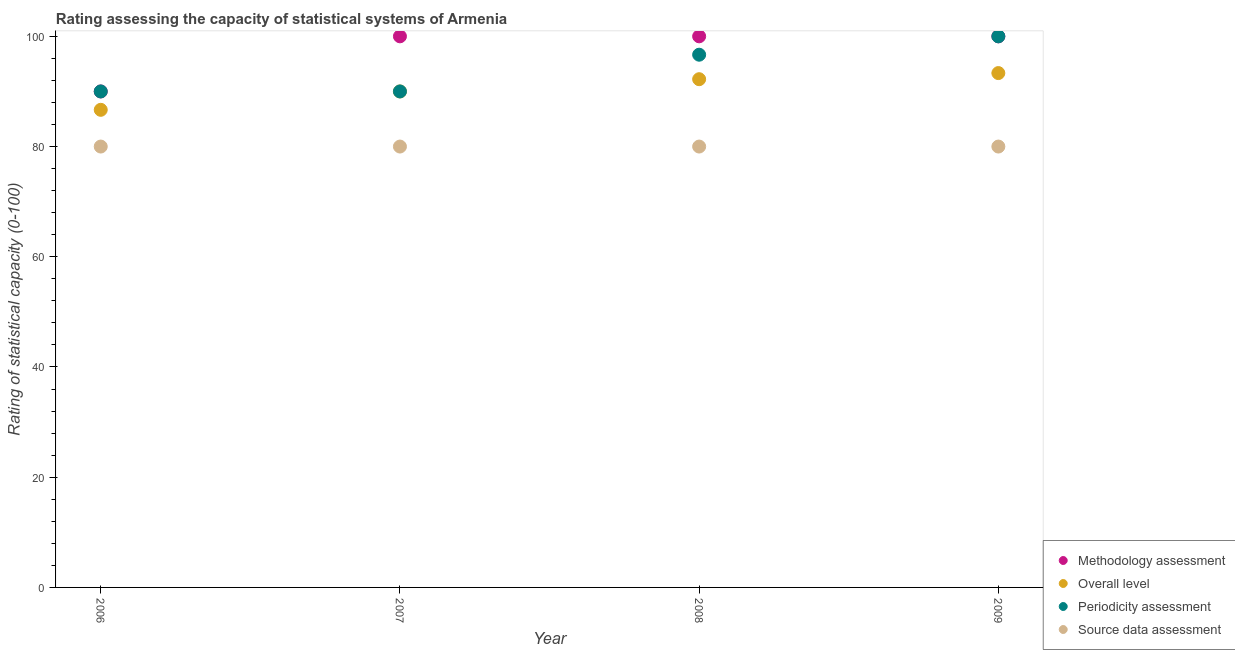How many different coloured dotlines are there?
Offer a terse response. 4. What is the source data assessment rating in 2008?
Your response must be concise. 80. Across all years, what is the maximum periodicity assessment rating?
Provide a short and direct response. 100. What is the total periodicity assessment rating in the graph?
Your answer should be compact. 376.67. What is the difference between the methodology assessment rating in 2006 and that in 2009?
Your answer should be very brief. -10. What is the difference between the overall level rating in 2007 and the source data assessment rating in 2008?
Keep it short and to the point. 10. What is the average overall level rating per year?
Keep it short and to the point. 90.56. In the year 2006, what is the difference between the methodology assessment rating and source data assessment rating?
Keep it short and to the point. 10. Is the difference between the methodology assessment rating in 2007 and 2008 greater than the difference between the overall level rating in 2007 and 2008?
Provide a succinct answer. Yes. What is the difference between the highest and the second highest periodicity assessment rating?
Keep it short and to the point. 3.33. Is the sum of the periodicity assessment rating in 2008 and 2009 greater than the maximum overall level rating across all years?
Your answer should be compact. Yes. Is it the case that in every year, the sum of the methodology assessment rating and overall level rating is greater than the periodicity assessment rating?
Provide a succinct answer. Yes. Does the periodicity assessment rating monotonically increase over the years?
Make the answer very short. No. How many years are there in the graph?
Ensure brevity in your answer.  4. What is the difference between two consecutive major ticks on the Y-axis?
Make the answer very short. 20. Does the graph contain any zero values?
Provide a short and direct response. No. Does the graph contain grids?
Give a very brief answer. No. What is the title of the graph?
Offer a terse response. Rating assessing the capacity of statistical systems of Armenia. Does "Social Insurance" appear as one of the legend labels in the graph?
Provide a short and direct response. No. What is the label or title of the Y-axis?
Your answer should be very brief. Rating of statistical capacity (0-100). What is the Rating of statistical capacity (0-100) in Overall level in 2006?
Ensure brevity in your answer.  86.67. What is the Rating of statistical capacity (0-100) in Source data assessment in 2006?
Provide a succinct answer. 80. What is the Rating of statistical capacity (0-100) of Methodology assessment in 2007?
Offer a terse response. 100. What is the Rating of statistical capacity (0-100) of Source data assessment in 2007?
Offer a very short reply. 80. What is the Rating of statistical capacity (0-100) of Methodology assessment in 2008?
Offer a terse response. 100. What is the Rating of statistical capacity (0-100) in Overall level in 2008?
Ensure brevity in your answer.  92.22. What is the Rating of statistical capacity (0-100) in Periodicity assessment in 2008?
Provide a succinct answer. 96.67. What is the Rating of statistical capacity (0-100) of Source data assessment in 2008?
Keep it short and to the point. 80. What is the Rating of statistical capacity (0-100) in Overall level in 2009?
Offer a very short reply. 93.33. Across all years, what is the maximum Rating of statistical capacity (0-100) in Methodology assessment?
Offer a very short reply. 100. Across all years, what is the maximum Rating of statistical capacity (0-100) in Overall level?
Provide a succinct answer. 93.33. Across all years, what is the maximum Rating of statistical capacity (0-100) of Periodicity assessment?
Provide a succinct answer. 100. Across all years, what is the minimum Rating of statistical capacity (0-100) of Methodology assessment?
Keep it short and to the point. 90. Across all years, what is the minimum Rating of statistical capacity (0-100) in Overall level?
Provide a short and direct response. 86.67. Across all years, what is the minimum Rating of statistical capacity (0-100) of Periodicity assessment?
Your answer should be very brief. 90. What is the total Rating of statistical capacity (0-100) of Methodology assessment in the graph?
Offer a very short reply. 390. What is the total Rating of statistical capacity (0-100) of Overall level in the graph?
Ensure brevity in your answer.  362.22. What is the total Rating of statistical capacity (0-100) in Periodicity assessment in the graph?
Offer a terse response. 376.67. What is the total Rating of statistical capacity (0-100) of Source data assessment in the graph?
Your response must be concise. 320. What is the difference between the Rating of statistical capacity (0-100) in Source data assessment in 2006 and that in 2007?
Provide a short and direct response. 0. What is the difference between the Rating of statistical capacity (0-100) of Methodology assessment in 2006 and that in 2008?
Ensure brevity in your answer.  -10. What is the difference between the Rating of statistical capacity (0-100) of Overall level in 2006 and that in 2008?
Your answer should be compact. -5.56. What is the difference between the Rating of statistical capacity (0-100) of Periodicity assessment in 2006 and that in 2008?
Keep it short and to the point. -6.67. What is the difference between the Rating of statistical capacity (0-100) in Overall level in 2006 and that in 2009?
Give a very brief answer. -6.67. What is the difference between the Rating of statistical capacity (0-100) in Periodicity assessment in 2006 and that in 2009?
Keep it short and to the point. -10. What is the difference between the Rating of statistical capacity (0-100) in Methodology assessment in 2007 and that in 2008?
Offer a terse response. 0. What is the difference between the Rating of statistical capacity (0-100) in Overall level in 2007 and that in 2008?
Your answer should be compact. -2.22. What is the difference between the Rating of statistical capacity (0-100) of Periodicity assessment in 2007 and that in 2008?
Your answer should be compact. -6.67. What is the difference between the Rating of statistical capacity (0-100) of Overall level in 2007 and that in 2009?
Ensure brevity in your answer.  -3.33. What is the difference between the Rating of statistical capacity (0-100) in Source data assessment in 2007 and that in 2009?
Provide a short and direct response. 0. What is the difference between the Rating of statistical capacity (0-100) in Overall level in 2008 and that in 2009?
Offer a terse response. -1.11. What is the difference between the Rating of statistical capacity (0-100) in Periodicity assessment in 2008 and that in 2009?
Keep it short and to the point. -3.33. What is the difference between the Rating of statistical capacity (0-100) of Source data assessment in 2008 and that in 2009?
Provide a succinct answer. 0. What is the difference between the Rating of statistical capacity (0-100) of Methodology assessment in 2006 and the Rating of statistical capacity (0-100) of Overall level in 2007?
Your answer should be very brief. 0. What is the difference between the Rating of statistical capacity (0-100) in Methodology assessment in 2006 and the Rating of statistical capacity (0-100) in Periodicity assessment in 2007?
Your answer should be very brief. 0. What is the difference between the Rating of statistical capacity (0-100) in Overall level in 2006 and the Rating of statistical capacity (0-100) in Periodicity assessment in 2007?
Provide a short and direct response. -3.33. What is the difference between the Rating of statistical capacity (0-100) of Methodology assessment in 2006 and the Rating of statistical capacity (0-100) of Overall level in 2008?
Your answer should be very brief. -2.22. What is the difference between the Rating of statistical capacity (0-100) in Methodology assessment in 2006 and the Rating of statistical capacity (0-100) in Periodicity assessment in 2008?
Offer a very short reply. -6.67. What is the difference between the Rating of statistical capacity (0-100) of Methodology assessment in 2006 and the Rating of statistical capacity (0-100) of Source data assessment in 2008?
Make the answer very short. 10. What is the difference between the Rating of statistical capacity (0-100) of Overall level in 2006 and the Rating of statistical capacity (0-100) of Periodicity assessment in 2008?
Keep it short and to the point. -10. What is the difference between the Rating of statistical capacity (0-100) in Periodicity assessment in 2006 and the Rating of statistical capacity (0-100) in Source data assessment in 2008?
Your answer should be compact. 10. What is the difference between the Rating of statistical capacity (0-100) of Overall level in 2006 and the Rating of statistical capacity (0-100) of Periodicity assessment in 2009?
Offer a terse response. -13.33. What is the difference between the Rating of statistical capacity (0-100) in Methodology assessment in 2007 and the Rating of statistical capacity (0-100) in Overall level in 2008?
Make the answer very short. 7.78. What is the difference between the Rating of statistical capacity (0-100) in Methodology assessment in 2007 and the Rating of statistical capacity (0-100) in Periodicity assessment in 2008?
Your answer should be compact. 3.33. What is the difference between the Rating of statistical capacity (0-100) in Overall level in 2007 and the Rating of statistical capacity (0-100) in Periodicity assessment in 2008?
Ensure brevity in your answer.  -6.67. What is the difference between the Rating of statistical capacity (0-100) of Methodology assessment in 2007 and the Rating of statistical capacity (0-100) of Overall level in 2009?
Offer a terse response. 6.67. What is the difference between the Rating of statistical capacity (0-100) of Methodology assessment in 2007 and the Rating of statistical capacity (0-100) of Source data assessment in 2009?
Your response must be concise. 20. What is the difference between the Rating of statistical capacity (0-100) in Overall level in 2007 and the Rating of statistical capacity (0-100) in Periodicity assessment in 2009?
Provide a succinct answer. -10. What is the difference between the Rating of statistical capacity (0-100) in Overall level in 2007 and the Rating of statistical capacity (0-100) in Source data assessment in 2009?
Keep it short and to the point. 10. What is the difference between the Rating of statistical capacity (0-100) in Periodicity assessment in 2007 and the Rating of statistical capacity (0-100) in Source data assessment in 2009?
Make the answer very short. 10. What is the difference between the Rating of statistical capacity (0-100) of Methodology assessment in 2008 and the Rating of statistical capacity (0-100) of Overall level in 2009?
Make the answer very short. 6.67. What is the difference between the Rating of statistical capacity (0-100) in Methodology assessment in 2008 and the Rating of statistical capacity (0-100) in Source data assessment in 2009?
Ensure brevity in your answer.  20. What is the difference between the Rating of statistical capacity (0-100) of Overall level in 2008 and the Rating of statistical capacity (0-100) of Periodicity assessment in 2009?
Make the answer very short. -7.78. What is the difference between the Rating of statistical capacity (0-100) in Overall level in 2008 and the Rating of statistical capacity (0-100) in Source data assessment in 2009?
Make the answer very short. 12.22. What is the difference between the Rating of statistical capacity (0-100) of Periodicity assessment in 2008 and the Rating of statistical capacity (0-100) of Source data assessment in 2009?
Give a very brief answer. 16.67. What is the average Rating of statistical capacity (0-100) of Methodology assessment per year?
Give a very brief answer. 97.5. What is the average Rating of statistical capacity (0-100) of Overall level per year?
Offer a terse response. 90.56. What is the average Rating of statistical capacity (0-100) in Periodicity assessment per year?
Your answer should be compact. 94.17. In the year 2006, what is the difference between the Rating of statistical capacity (0-100) in Methodology assessment and Rating of statistical capacity (0-100) in Periodicity assessment?
Ensure brevity in your answer.  0. In the year 2007, what is the difference between the Rating of statistical capacity (0-100) in Methodology assessment and Rating of statistical capacity (0-100) in Source data assessment?
Offer a terse response. 20. In the year 2007, what is the difference between the Rating of statistical capacity (0-100) in Overall level and Rating of statistical capacity (0-100) in Source data assessment?
Offer a terse response. 10. In the year 2008, what is the difference between the Rating of statistical capacity (0-100) of Methodology assessment and Rating of statistical capacity (0-100) of Overall level?
Offer a very short reply. 7.78. In the year 2008, what is the difference between the Rating of statistical capacity (0-100) in Methodology assessment and Rating of statistical capacity (0-100) in Periodicity assessment?
Offer a terse response. 3.33. In the year 2008, what is the difference between the Rating of statistical capacity (0-100) of Overall level and Rating of statistical capacity (0-100) of Periodicity assessment?
Your response must be concise. -4.44. In the year 2008, what is the difference between the Rating of statistical capacity (0-100) of Overall level and Rating of statistical capacity (0-100) of Source data assessment?
Give a very brief answer. 12.22. In the year 2008, what is the difference between the Rating of statistical capacity (0-100) in Periodicity assessment and Rating of statistical capacity (0-100) in Source data assessment?
Keep it short and to the point. 16.67. In the year 2009, what is the difference between the Rating of statistical capacity (0-100) of Methodology assessment and Rating of statistical capacity (0-100) of Overall level?
Give a very brief answer. 6.67. In the year 2009, what is the difference between the Rating of statistical capacity (0-100) of Methodology assessment and Rating of statistical capacity (0-100) of Source data assessment?
Ensure brevity in your answer.  20. In the year 2009, what is the difference between the Rating of statistical capacity (0-100) in Overall level and Rating of statistical capacity (0-100) in Periodicity assessment?
Provide a short and direct response. -6.67. In the year 2009, what is the difference between the Rating of statistical capacity (0-100) in Overall level and Rating of statistical capacity (0-100) in Source data assessment?
Provide a succinct answer. 13.33. What is the ratio of the Rating of statistical capacity (0-100) in Overall level in 2006 to that in 2007?
Your answer should be very brief. 0.96. What is the ratio of the Rating of statistical capacity (0-100) in Source data assessment in 2006 to that in 2007?
Keep it short and to the point. 1. What is the ratio of the Rating of statistical capacity (0-100) of Methodology assessment in 2006 to that in 2008?
Ensure brevity in your answer.  0.9. What is the ratio of the Rating of statistical capacity (0-100) of Overall level in 2006 to that in 2008?
Provide a succinct answer. 0.94. What is the ratio of the Rating of statistical capacity (0-100) in Periodicity assessment in 2006 to that in 2008?
Your response must be concise. 0.93. What is the ratio of the Rating of statistical capacity (0-100) in Source data assessment in 2006 to that in 2009?
Keep it short and to the point. 1. What is the ratio of the Rating of statistical capacity (0-100) of Overall level in 2007 to that in 2008?
Offer a terse response. 0.98. What is the ratio of the Rating of statistical capacity (0-100) in Periodicity assessment in 2007 to that in 2008?
Provide a succinct answer. 0.93. What is the ratio of the Rating of statistical capacity (0-100) in Source data assessment in 2007 to that in 2008?
Offer a terse response. 1. What is the ratio of the Rating of statistical capacity (0-100) in Source data assessment in 2007 to that in 2009?
Your answer should be very brief. 1. What is the ratio of the Rating of statistical capacity (0-100) of Overall level in 2008 to that in 2009?
Keep it short and to the point. 0.99. What is the ratio of the Rating of statistical capacity (0-100) of Periodicity assessment in 2008 to that in 2009?
Ensure brevity in your answer.  0.97. What is the difference between the highest and the second highest Rating of statistical capacity (0-100) in Methodology assessment?
Provide a succinct answer. 0. What is the difference between the highest and the second highest Rating of statistical capacity (0-100) in Overall level?
Offer a very short reply. 1.11. What is the difference between the highest and the second highest Rating of statistical capacity (0-100) in Periodicity assessment?
Offer a terse response. 3.33. What is the difference between the highest and the second highest Rating of statistical capacity (0-100) in Source data assessment?
Offer a very short reply. 0. What is the difference between the highest and the lowest Rating of statistical capacity (0-100) in Methodology assessment?
Your answer should be compact. 10. 